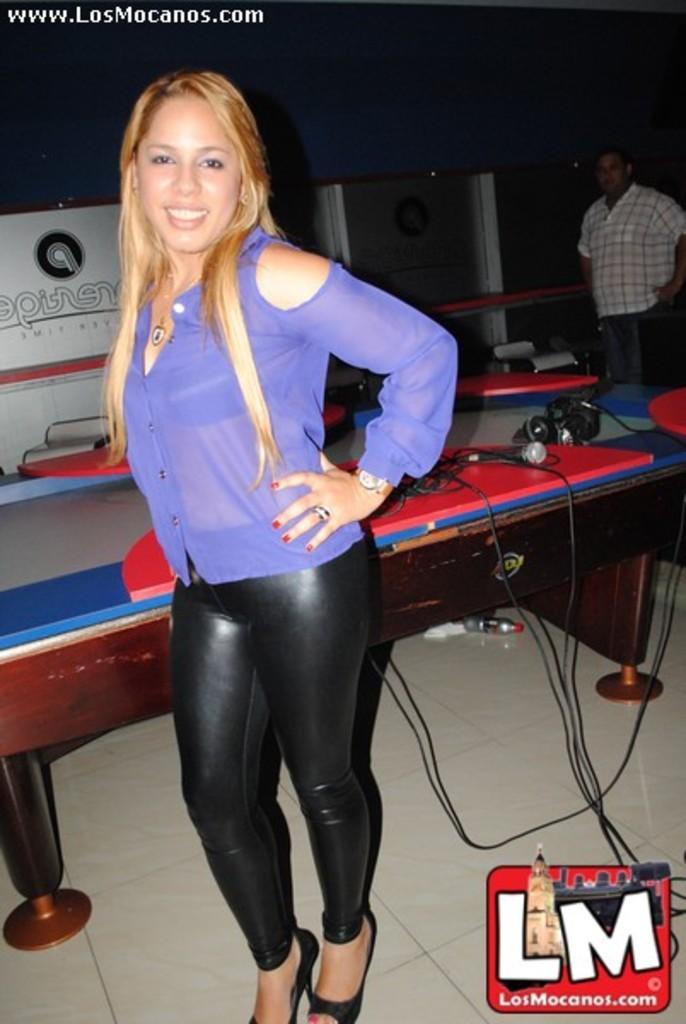How would you summarize this image in a sentence or two? Here we can see that a woman is standing on the floor, and smiling and at back her is the table and microphone and some objects on it, and here a person is standing. 